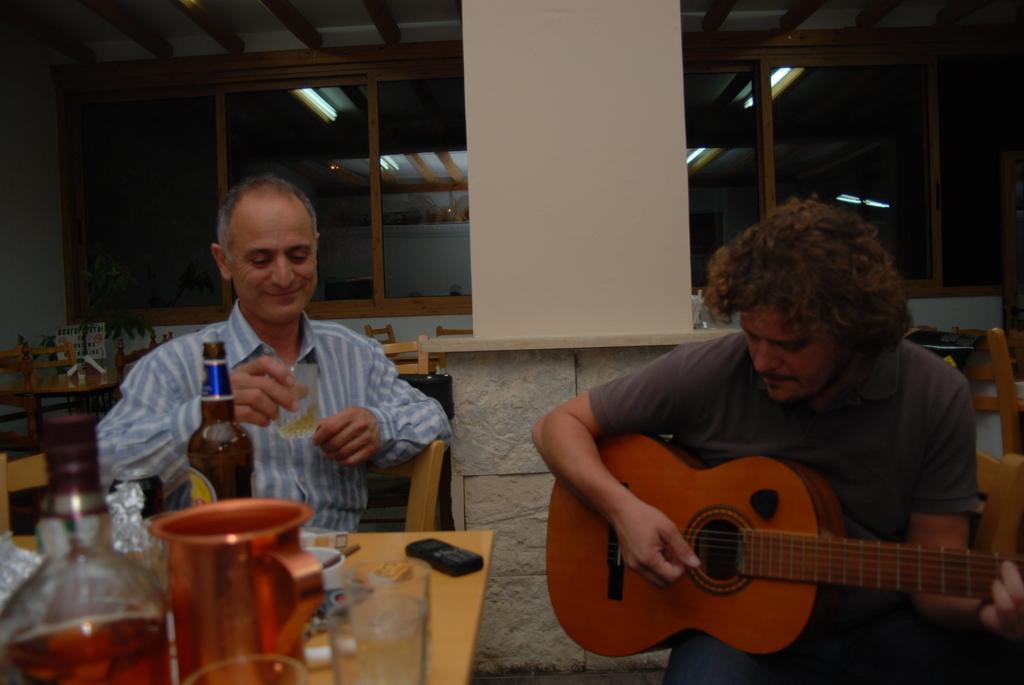How would you summarize this image in a sentence or two? In this picture we can see two persons. He is holding a glass with his hand and he is playing guitar. This is table. On the table there is a jar, glasses, bottle, and a mobile. This is pillar. On the background we can see lights and this is wall. 